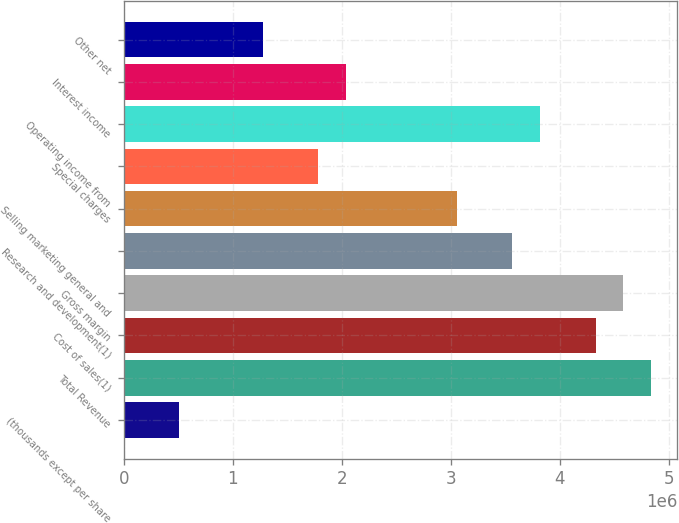Convert chart to OTSL. <chart><loc_0><loc_0><loc_500><loc_500><bar_chart><fcel>(thousands except per share<fcel>Total Revenue<fcel>Cost of sales(1)<fcel>Gross margin<fcel>Research and development(1)<fcel>Selling marketing general and<fcel>Special charges<fcel>Operating income from<fcel>Interest income<fcel>Other net<nl><fcel>509224<fcel>4.83762e+06<fcel>4.3284e+06<fcel>4.58301e+06<fcel>3.56456e+06<fcel>3.05534e+06<fcel>1.78228e+06<fcel>3.81918e+06<fcel>2.03689e+06<fcel>1.27306e+06<nl></chart> 